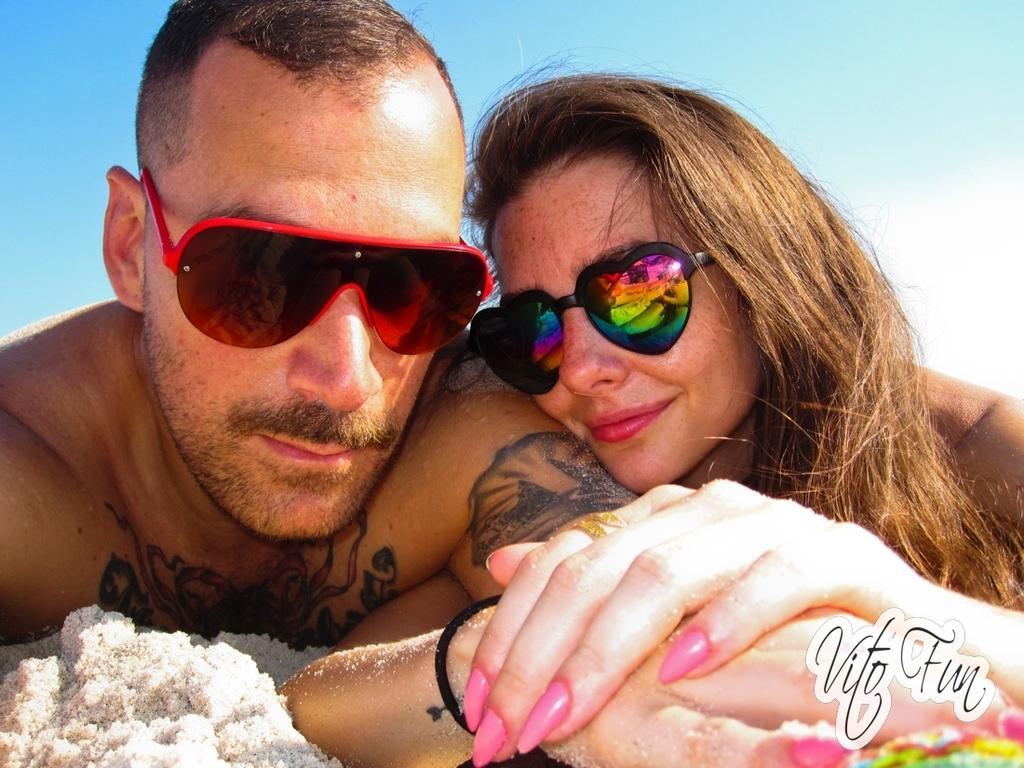Can you describe this image briefly? In this image, I can see the man and woman smiling. They wore goggles. I think this is a sand. Here is the sky. This looks like a watermark on the image. 